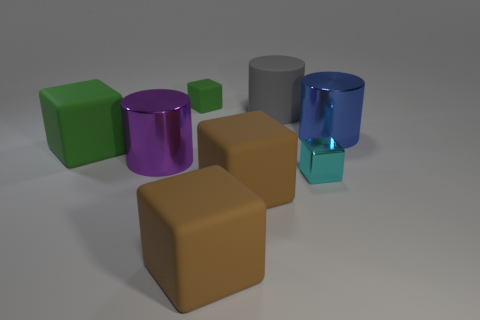Add 1 purple metal cylinders. How many objects exist? 9 Subtract all brown blocks. How many blocks are left? 3 Subtract all brown cubes. How many cubes are left? 3 Subtract all blocks. How many objects are left? 3 Subtract 3 cylinders. How many cylinders are left? 0 Subtract all green blocks. Subtract all cyan cylinders. How many blocks are left? 3 Subtract all yellow cylinders. How many green cubes are left? 2 Subtract all big gray matte objects. Subtract all big green rubber blocks. How many objects are left? 6 Add 2 big objects. How many big objects are left? 8 Add 5 gray shiny blocks. How many gray shiny blocks exist? 5 